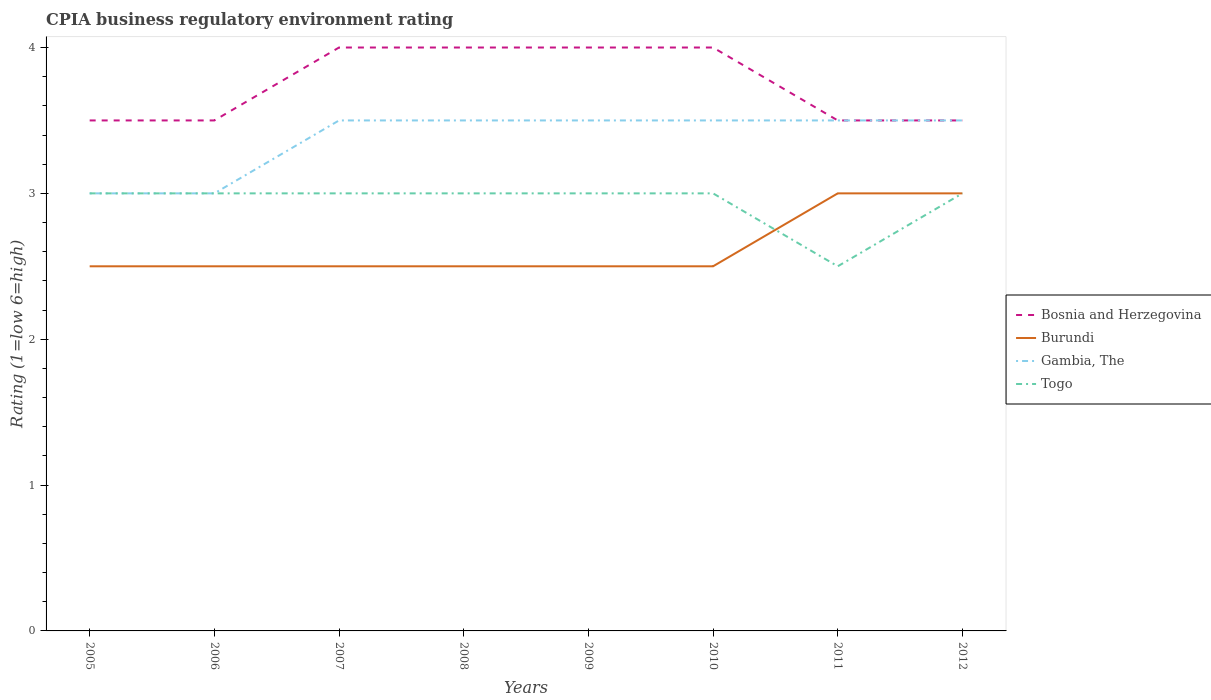Does the line corresponding to Bosnia and Herzegovina intersect with the line corresponding to Togo?
Provide a short and direct response. No. Across all years, what is the maximum CPIA rating in Gambia, The?
Provide a short and direct response. 3. In which year was the CPIA rating in Gambia, The maximum?
Keep it short and to the point. 2005. What is the total CPIA rating in Burundi in the graph?
Offer a terse response. -0.5. What is the difference between the highest and the second highest CPIA rating in Bosnia and Herzegovina?
Provide a short and direct response. 0.5. What is the difference between the highest and the lowest CPIA rating in Burundi?
Provide a short and direct response. 2. Is the CPIA rating in Gambia, The strictly greater than the CPIA rating in Togo over the years?
Give a very brief answer. No. How many lines are there?
Provide a succinct answer. 4. How many years are there in the graph?
Your answer should be compact. 8. Are the values on the major ticks of Y-axis written in scientific E-notation?
Offer a very short reply. No. Does the graph contain any zero values?
Give a very brief answer. No. How are the legend labels stacked?
Provide a short and direct response. Vertical. What is the title of the graph?
Keep it short and to the point. CPIA business regulatory environment rating. Does "Small states" appear as one of the legend labels in the graph?
Your answer should be very brief. No. What is the Rating (1=low 6=high) of Bosnia and Herzegovina in 2005?
Give a very brief answer. 3.5. What is the Rating (1=low 6=high) in Togo in 2006?
Provide a short and direct response. 3. What is the Rating (1=low 6=high) in Burundi in 2007?
Your answer should be very brief. 2.5. What is the Rating (1=low 6=high) in Togo in 2007?
Give a very brief answer. 3. What is the Rating (1=low 6=high) in Bosnia and Herzegovina in 2008?
Your answer should be compact. 4. What is the Rating (1=low 6=high) in Bosnia and Herzegovina in 2009?
Give a very brief answer. 4. What is the Rating (1=low 6=high) of Burundi in 2009?
Keep it short and to the point. 2.5. What is the Rating (1=low 6=high) of Gambia, The in 2009?
Provide a short and direct response. 3.5. What is the Rating (1=low 6=high) of Togo in 2010?
Keep it short and to the point. 3. What is the Rating (1=low 6=high) in Burundi in 2011?
Your response must be concise. 3. What is the Rating (1=low 6=high) in Bosnia and Herzegovina in 2012?
Ensure brevity in your answer.  3.5. What is the Rating (1=low 6=high) in Burundi in 2012?
Provide a short and direct response. 3. What is the Rating (1=low 6=high) in Gambia, The in 2012?
Provide a succinct answer. 3.5. What is the Rating (1=low 6=high) in Togo in 2012?
Give a very brief answer. 3. Across all years, what is the maximum Rating (1=low 6=high) in Bosnia and Herzegovina?
Offer a terse response. 4. Across all years, what is the minimum Rating (1=low 6=high) of Burundi?
Your response must be concise. 2.5. Across all years, what is the minimum Rating (1=low 6=high) in Gambia, The?
Provide a short and direct response. 3. Across all years, what is the minimum Rating (1=low 6=high) in Togo?
Your answer should be very brief. 2.5. What is the total Rating (1=low 6=high) in Burundi in the graph?
Offer a very short reply. 21. What is the total Rating (1=low 6=high) in Togo in the graph?
Make the answer very short. 23.5. What is the difference between the Rating (1=low 6=high) of Bosnia and Herzegovina in 2005 and that in 2006?
Make the answer very short. 0. What is the difference between the Rating (1=low 6=high) in Burundi in 2005 and that in 2006?
Make the answer very short. 0. What is the difference between the Rating (1=low 6=high) in Gambia, The in 2005 and that in 2006?
Provide a succinct answer. 0. What is the difference between the Rating (1=low 6=high) in Togo in 2005 and that in 2006?
Ensure brevity in your answer.  0. What is the difference between the Rating (1=low 6=high) in Togo in 2005 and that in 2007?
Your answer should be very brief. 0. What is the difference between the Rating (1=low 6=high) in Bosnia and Herzegovina in 2005 and that in 2008?
Provide a succinct answer. -0.5. What is the difference between the Rating (1=low 6=high) in Burundi in 2005 and that in 2008?
Provide a succinct answer. 0. What is the difference between the Rating (1=low 6=high) of Togo in 2005 and that in 2008?
Ensure brevity in your answer.  0. What is the difference between the Rating (1=low 6=high) of Bosnia and Herzegovina in 2005 and that in 2009?
Offer a terse response. -0.5. What is the difference between the Rating (1=low 6=high) in Gambia, The in 2005 and that in 2009?
Give a very brief answer. -0.5. What is the difference between the Rating (1=low 6=high) in Burundi in 2005 and that in 2010?
Provide a succinct answer. 0. What is the difference between the Rating (1=low 6=high) of Gambia, The in 2005 and that in 2010?
Ensure brevity in your answer.  -0.5. What is the difference between the Rating (1=low 6=high) of Togo in 2005 and that in 2010?
Keep it short and to the point. 0. What is the difference between the Rating (1=low 6=high) in Togo in 2005 and that in 2011?
Make the answer very short. 0.5. What is the difference between the Rating (1=low 6=high) in Bosnia and Herzegovina in 2005 and that in 2012?
Provide a succinct answer. 0. What is the difference between the Rating (1=low 6=high) in Gambia, The in 2005 and that in 2012?
Your answer should be compact. -0.5. What is the difference between the Rating (1=low 6=high) of Burundi in 2006 and that in 2007?
Offer a terse response. 0. What is the difference between the Rating (1=low 6=high) in Bosnia and Herzegovina in 2006 and that in 2008?
Keep it short and to the point. -0.5. What is the difference between the Rating (1=low 6=high) of Gambia, The in 2006 and that in 2008?
Provide a succinct answer. -0.5. What is the difference between the Rating (1=low 6=high) of Togo in 2006 and that in 2008?
Make the answer very short. 0. What is the difference between the Rating (1=low 6=high) in Bosnia and Herzegovina in 2006 and that in 2009?
Your answer should be compact. -0.5. What is the difference between the Rating (1=low 6=high) of Gambia, The in 2006 and that in 2009?
Provide a succinct answer. -0.5. What is the difference between the Rating (1=low 6=high) in Togo in 2006 and that in 2009?
Make the answer very short. 0. What is the difference between the Rating (1=low 6=high) in Bosnia and Herzegovina in 2006 and that in 2010?
Your answer should be very brief. -0.5. What is the difference between the Rating (1=low 6=high) in Burundi in 2006 and that in 2010?
Give a very brief answer. 0. What is the difference between the Rating (1=low 6=high) in Gambia, The in 2006 and that in 2010?
Your answer should be compact. -0.5. What is the difference between the Rating (1=low 6=high) in Togo in 2006 and that in 2010?
Give a very brief answer. 0. What is the difference between the Rating (1=low 6=high) of Burundi in 2006 and that in 2011?
Offer a very short reply. -0.5. What is the difference between the Rating (1=low 6=high) of Togo in 2006 and that in 2011?
Keep it short and to the point. 0.5. What is the difference between the Rating (1=low 6=high) in Burundi in 2006 and that in 2012?
Offer a terse response. -0.5. What is the difference between the Rating (1=low 6=high) in Gambia, The in 2006 and that in 2012?
Ensure brevity in your answer.  -0.5. What is the difference between the Rating (1=low 6=high) of Bosnia and Herzegovina in 2007 and that in 2008?
Ensure brevity in your answer.  0. What is the difference between the Rating (1=low 6=high) in Burundi in 2007 and that in 2008?
Make the answer very short. 0. What is the difference between the Rating (1=low 6=high) of Gambia, The in 2007 and that in 2008?
Offer a terse response. 0. What is the difference between the Rating (1=low 6=high) of Burundi in 2007 and that in 2009?
Offer a very short reply. 0. What is the difference between the Rating (1=low 6=high) of Togo in 2007 and that in 2009?
Your response must be concise. 0. What is the difference between the Rating (1=low 6=high) of Burundi in 2007 and that in 2010?
Your answer should be very brief. 0. What is the difference between the Rating (1=low 6=high) in Togo in 2007 and that in 2010?
Your answer should be compact. 0. What is the difference between the Rating (1=low 6=high) of Bosnia and Herzegovina in 2007 and that in 2011?
Your response must be concise. 0.5. What is the difference between the Rating (1=low 6=high) of Burundi in 2007 and that in 2011?
Ensure brevity in your answer.  -0.5. What is the difference between the Rating (1=low 6=high) in Bosnia and Herzegovina in 2008 and that in 2010?
Offer a very short reply. 0. What is the difference between the Rating (1=low 6=high) of Burundi in 2008 and that in 2010?
Offer a terse response. 0. What is the difference between the Rating (1=low 6=high) of Togo in 2008 and that in 2010?
Provide a succinct answer. 0. What is the difference between the Rating (1=low 6=high) of Bosnia and Herzegovina in 2008 and that in 2011?
Keep it short and to the point. 0.5. What is the difference between the Rating (1=low 6=high) in Burundi in 2008 and that in 2011?
Your answer should be very brief. -0.5. What is the difference between the Rating (1=low 6=high) of Burundi in 2008 and that in 2012?
Ensure brevity in your answer.  -0.5. What is the difference between the Rating (1=low 6=high) in Gambia, The in 2008 and that in 2012?
Provide a short and direct response. 0. What is the difference between the Rating (1=low 6=high) in Togo in 2008 and that in 2012?
Your answer should be compact. 0. What is the difference between the Rating (1=low 6=high) in Bosnia and Herzegovina in 2009 and that in 2010?
Your response must be concise. 0. What is the difference between the Rating (1=low 6=high) in Togo in 2009 and that in 2010?
Make the answer very short. 0. What is the difference between the Rating (1=low 6=high) in Burundi in 2009 and that in 2011?
Offer a terse response. -0.5. What is the difference between the Rating (1=low 6=high) in Togo in 2009 and that in 2011?
Make the answer very short. 0.5. What is the difference between the Rating (1=low 6=high) of Bosnia and Herzegovina in 2010 and that in 2011?
Offer a terse response. 0.5. What is the difference between the Rating (1=low 6=high) in Burundi in 2010 and that in 2011?
Offer a terse response. -0.5. What is the difference between the Rating (1=low 6=high) of Togo in 2010 and that in 2011?
Your answer should be compact. 0.5. What is the difference between the Rating (1=low 6=high) of Bosnia and Herzegovina in 2010 and that in 2012?
Your answer should be very brief. 0.5. What is the difference between the Rating (1=low 6=high) of Togo in 2010 and that in 2012?
Make the answer very short. 0. What is the difference between the Rating (1=low 6=high) of Burundi in 2011 and that in 2012?
Your response must be concise. 0. What is the difference between the Rating (1=low 6=high) of Togo in 2011 and that in 2012?
Make the answer very short. -0.5. What is the difference between the Rating (1=low 6=high) in Bosnia and Herzegovina in 2005 and the Rating (1=low 6=high) in Togo in 2006?
Your answer should be compact. 0.5. What is the difference between the Rating (1=low 6=high) in Burundi in 2005 and the Rating (1=low 6=high) in Togo in 2006?
Your response must be concise. -0.5. What is the difference between the Rating (1=low 6=high) in Gambia, The in 2005 and the Rating (1=low 6=high) in Togo in 2006?
Your answer should be very brief. 0. What is the difference between the Rating (1=low 6=high) of Bosnia and Herzegovina in 2005 and the Rating (1=low 6=high) of Burundi in 2007?
Provide a short and direct response. 1. What is the difference between the Rating (1=low 6=high) of Burundi in 2005 and the Rating (1=low 6=high) of Togo in 2007?
Provide a short and direct response. -0.5. What is the difference between the Rating (1=low 6=high) in Bosnia and Herzegovina in 2005 and the Rating (1=low 6=high) in Burundi in 2008?
Keep it short and to the point. 1. What is the difference between the Rating (1=low 6=high) of Bosnia and Herzegovina in 2005 and the Rating (1=low 6=high) of Gambia, The in 2008?
Offer a terse response. 0. What is the difference between the Rating (1=low 6=high) in Gambia, The in 2005 and the Rating (1=low 6=high) in Togo in 2008?
Ensure brevity in your answer.  0. What is the difference between the Rating (1=low 6=high) in Bosnia and Herzegovina in 2005 and the Rating (1=low 6=high) in Gambia, The in 2009?
Give a very brief answer. 0. What is the difference between the Rating (1=low 6=high) in Gambia, The in 2005 and the Rating (1=low 6=high) in Togo in 2009?
Provide a succinct answer. 0. What is the difference between the Rating (1=low 6=high) in Bosnia and Herzegovina in 2005 and the Rating (1=low 6=high) in Burundi in 2010?
Provide a short and direct response. 1. What is the difference between the Rating (1=low 6=high) in Bosnia and Herzegovina in 2005 and the Rating (1=low 6=high) in Gambia, The in 2010?
Provide a short and direct response. 0. What is the difference between the Rating (1=low 6=high) of Bosnia and Herzegovina in 2005 and the Rating (1=low 6=high) of Togo in 2010?
Offer a terse response. 0.5. What is the difference between the Rating (1=low 6=high) of Burundi in 2005 and the Rating (1=low 6=high) of Gambia, The in 2010?
Your answer should be compact. -1. What is the difference between the Rating (1=low 6=high) of Burundi in 2005 and the Rating (1=low 6=high) of Togo in 2010?
Offer a terse response. -0.5. What is the difference between the Rating (1=low 6=high) in Gambia, The in 2005 and the Rating (1=low 6=high) in Togo in 2010?
Give a very brief answer. 0. What is the difference between the Rating (1=low 6=high) in Bosnia and Herzegovina in 2005 and the Rating (1=low 6=high) in Burundi in 2011?
Provide a short and direct response. 0.5. What is the difference between the Rating (1=low 6=high) of Bosnia and Herzegovina in 2005 and the Rating (1=low 6=high) of Togo in 2011?
Keep it short and to the point. 1. What is the difference between the Rating (1=low 6=high) of Burundi in 2005 and the Rating (1=low 6=high) of Gambia, The in 2011?
Provide a succinct answer. -1. What is the difference between the Rating (1=low 6=high) in Bosnia and Herzegovina in 2005 and the Rating (1=low 6=high) in Burundi in 2012?
Ensure brevity in your answer.  0.5. What is the difference between the Rating (1=low 6=high) of Burundi in 2005 and the Rating (1=low 6=high) of Togo in 2012?
Your answer should be compact. -0.5. What is the difference between the Rating (1=low 6=high) of Gambia, The in 2005 and the Rating (1=low 6=high) of Togo in 2012?
Provide a succinct answer. 0. What is the difference between the Rating (1=low 6=high) in Bosnia and Herzegovina in 2006 and the Rating (1=low 6=high) in Gambia, The in 2007?
Provide a short and direct response. 0. What is the difference between the Rating (1=low 6=high) in Burundi in 2006 and the Rating (1=low 6=high) in Togo in 2008?
Ensure brevity in your answer.  -0.5. What is the difference between the Rating (1=low 6=high) of Gambia, The in 2006 and the Rating (1=low 6=high) of Togo in 2008?
Provide a succinct answer. 0. What is the difference between the Rating (1=low 6=high) in Burundi in 2006 and the Rating (1=low 6=high) in Gambia, The in 2009?
Ensure brevity in your answer.  -1. What is the difference between the Rating (1=low 6=high) of Gambia, The in 2006 and the Rating (1=low 6=high) of Togo in 2009?
Make the answer very short. 0. What is the difference between the Rating (1=low 6=high) of Bosnia and Herzegovina in 2006 and the Rating (1=low 6=high) of Togo in 2010?
Your answer should be compact. 0.5. What is the difference between the Rating (1=low 6=high) of Burundi in 2006 and the Rating (1=low 6=high) of Togo in 2010?
Offer a very short reply. -0.5. What is the difference between the Rating (1=low 6=high) in Gambia, The in 2006 and the Rating (1=low 6=high) in Togo in 2010?
Provide a succinct answer. 0. What is the difference between the Rating (1=low 6=high) in Bosnia and Herzegovina in 2006 and the Rating (1=low 6=high) in Gambia, The in 2011?
Provide a succinct answer. 0. What is the difference between the Rating (1=low 6=high) of Bosnia and Herzegovina in 2006 and the Rating (1=low 6=high) of Togo in 2011?
Provide a short and direct response. 1. What is the difference between the Rating (1=low 6=high) in Gambia, The in 2006 and the Rating (1=low 6=high) in Togo in 2011?
Provide a succinct answer. 0.5. What is the difference between the Rating (1=low 6=high) of Bosnia and Herzegovina in 2006 and the Rating (1=low 6=high) of Togo in 2012?
Ensure brevity in your answer.  0.5. What is the difference between the Rating (1=low 6=high) of Burundi in 2006 and the Rating (1=low 6=high) of Gambia, The in 2012?
Offer a terse response. -1. What is the difference between the Rating (1=low 6=high) of Burundi in 2006 and the Rating (1=low 6=high) of Togo in 2012?
Ensure brevity in your answer.  -0.5. What is the difference between the Rating (1=low 6=high) of Gambia, The in 2006 and the Rating (1=low 6=high) of Togo in 2012?
Give a very brief answer. 0. What is the difference between the Rating (1=low 6=high) in Bosnia and Herzegovina in 2007 and the Rating (1=low 6=high) in Burundi in 2008?
Your answer should be compact. 1.5. What is the difference between the Rating (1=low 6=high) of Bosnia and Herzegovina in 2007 and the Rating (1=low 6=high) of Gambia, The in 2008?
Your answer should be very brief. 0.5. What is the difference between the Rating (1=low 6=high) in Burundi in 2007 and the Rating (1=low 6=high) in Gambia, The in 2008?
Your answer should be compact. -1. What is the difference between the Rating (1=low 6=high) of Burundi in 2007 and the Rating (1=low 6=high) of Togo in 2008?
Your response must be concise. -0.5. What is the difference between the Rating (1=low 6=high) in Gambia, The in 2007 and the Rating (1=low 6=high) in Togo in 2008?
Give a very brief answer. 0.5. What is the difference between the Rating (1=low 6=high) in Bosnia and Herzegovina in 2007 and the Rating (1=low 6=high) in Burundi in 2009?
Your answer should be compact. 1.5. What is the difference between the Rating (1=low 6=high) of Bosnia and Herzegovina in 2007 and the Rating (1=low 6=high) of Gambia, The in 2009?
Offer a terse response. 0.5. What is the difference between the Rating (1=low 6=high) in Bosnia and Herzegovina in 2007 and the Rating (1=low 6=high) in Togo in 2009?
Provide a succinct answer. 1. What is the difference between the Rating (1=low 6=high) in Burundi in 2007 and the Rating (1=low 6=high) in Gambia, The in 2009?
Offer a terse response. -1. What is the difference between the Rating (1=low 6=high) of Burundi in 2007 and the Rating (1=low 6=high) of Togo in 2009?
Your answer should be very brief. -0.5. What is the difference between the Rating (1=low 6=high) of Bosnia and Herzegovina in 2007 and the Rating (1=low 6=high) of Togo in 2010?
Keep it short and to the point. 1. What is the difference between the Rating (1=low 6=high) of Burundi in 2007 and the Rating (1=low 6=high) of Gambia, The in 2010?
Keep it short and to the point. -1. What is the difference between the Rating (1=low 6=high) in Burundi in 2007 and the Rating (1=low 6=high) in Togo in 2010?
Provide a succinct answer. -0.5. What is the difference between the Rating (1=low 6=high) of Gambia, The in 2007 and the Rating (1=low 6=high) of Togo in 2010?
Provide a succinct answer. 0.5. What is the difference between the Rating (1=low 6=high) of Bosnia and Herzegovina in 2007 and the Rating (1=low 6=high) of Burundi in 2011?
Make the answer very short. 1. What is the difference between the Rating (1=low 6=high) of Bosnia and Herzegovina in 2007 and the Rating (1=low 6=high) of Togo in 2011?
Your response must be concise. 1.5. What is the difference between the Rating (1=low 6=high) of Burundi in 2007 and the Rating (1=low 6=high) of Gambia, The in 2011?
Give a very brief answer. -1. What is the difference between the Rating (1=low 6=high) in Bosnia and Herzegovina in 2007 and the Rating (1=low 6=high) in Togo in 2012?
Ensure brevity in your answer.  1. What is the difference between the Rating (1=low 6=high) of Burundi in 2007 and the Rating (1=low 6=high) of Togo in 2012?
Keep it short and to the point. -0.5. What is the difference between the Rating (1=low 6=high) of Gambia, The in 2007 and the Rating (1=low 6=high) of Togo in 2012?
Provide a succinct answer. 0.5. What is the difference between the Rating (1=low 6=high) of Bosnia and Herzegovina in 2008 and the Rating (1=low 6=high) of Gambia, The in 2009?
Give a very brief answer. 0.5. What is the difference between the Rating (1=low 6=high) in Bosnia and Herzegovina in 2008 and the Rating (1=low 6=high) in Togo in 2009?
Ensure brevity in your answer.  1. What is the difference between the Rating (1=low 6=high) of Burundi in 2008 and the Rating (1=low 6=high) of Gambia, The in 2009?
Your response must be concise. -1. What is the difference between the Rating (1=low 6=high) in Gambia, The in 2008 and the Rating (1=low 6=high) in Togo in 2009?
Give a very brief answer. 0.5. What is the difference between the Rating (1=low 6=high) in Bosnia and Herzegovina in 2008 and the Rating (1=low 6=high) in Gambia, The in 2010?
Offer a terse response. 0.5. What is the difference between the Rating (1=low 6=high) of Bosnia and Herzegovina in 2008 and the Rating (1=low 6=high) of Togo in 2010?
Provide a succinct answer. 1. What is the difference between the Rating (1=low 6=high) of Burundi in 2008 and the Rating (1=low 6=high) of Gambia, The in 2010?
Offer a terse response. -1. What is the difference between the Rating (1=low 6=high) of Gambia, The in 2008 and the Rating (1=low 6=high) of Togo in 2010?
Keep it short and to the point. 0.5. What is the difference between the Rating (1=low 6=high) of Bosnia and Herzegovina in 2008 and the Rating (1=low 6=high) of Burundi in 2011?
Give a very brief answer. 1. What is the difference between the Rating (1=low 6=high) in Bosnia and Herzegovina in 2008 and the Rating (1=low 6=high) in Togo in 2011?
Offer a terse response. 1.5. What is the difference between the Rating (1=low 6=high) of Burundi in 2008 and the Rating (1=low 6=high) of Togo in 2011?
Your response must be concise. 0. What is the difference between the Rating (1=low 6=high) in Bosnia and Herzegovina in 2008 and the Rating (1=low 6=high) in Gambia, The in 2012?
Your answer should be very brief. 0.5. What is the difference between the Rating (1=low 6=high) in Bosnia and Herzegovina in 2008 and the Rating (1=low 6=high) in Togo in 2012?
Make the answer very short. 1. What is the difference between the Rating (1=low 6=high) of Burundi in 2008 and the Rating (1=low 6=high) of Togo in 2012?
Give a very brief answer. -0.5. What is the difference between the Rating (1=low 6=high) in Bosnia and Herzegovina in 2009 and the Rating (1=low 6=high) in Burundi in 2010?
Your answer should be very brief. 1.5. What is the difference between the Rating (1=low 6=high) in Bosnia and Herzegovina in 2009 and the Rating (1=low 6=high) in Togo in 2010?
Your response must be concise. 1. What is the difference between the Rating (1=low 6=high) of Burundi in 2009 and the Rating (1=low 6=high) of Gambia, The in 2010?
Your answer should be very brief. -1. What is the difference between the Rating (1=low 6=high) of Gambia, The in 2009 and the Rating (1=low 6=high) of Togo in 2010?
Ensure brevity in your answer.  0.5. What is the difference between the Rating (1=low 6=high) in Bosnia and Herzegovina in 2009 and the Rating (1=low 6=high) in Togo in 2011?
Provide a short and direct response. 1.5. What is the difference between the Rating (1=low 6=high) in Burundi in 2009 and the Rating (1=low 6=high) in Gambia, The in 2011?
Give a very brief answer. -1. What is the difference between the Rating (1=low 6=high) of Gambia, The in 2009 and the Rating (1=low 6=high) of Togo in 2011?
Make the answer very short. 1. What is the difference between the Rating (1=low 6=high) in Bosnia and Herzegovina in 2009 and the Rating (1=low 6=high) in Togo in 2012?
Provide a succinct answer. 1. What is the difference between the Rating (1=low 6=high) in Burundi in 2009 and the Rating (1=low 6=high) in Gambia, The in 2012?
Your answer should be compact. -1. What is the difference between the Rating (1=low 6=high) of Bosnia and Herzegovina in 2010 and the Rating (1=low 6=high) of Burundi in 2011?
Make the answer very short. 1. What is the difference between the Rating (1=low 6=high) of Burundi in 2010 and the Rating (1=low 6=high) of Togo in 2011?
Your answer should be compact. 0. What is the difference between the Rating (1=low 6=high) of Gambia, The in 2010 and the Rating (1=low 6=high) of Togo in 2011?
Your answer should be very brief. 1. What is the difference between the Rating (1=low 6=high) in Bosnia and Herzegovina in 2010 and the Rating (1=low 6=high) in Togo in 2012?
Offer a terse response. 1. What is the difference between the Rating (1=low 6=high) of Burundi in 2010 and the Rating (1=low 6=high) of Gambia, The in 2012?
Provide a short and direct response. -1. What is the difference between the Rating (1=low 6=high) in Gambia, The in 2010 and the Rating (1=low 6=high) in Togo in 2012?
Offer a terse response. 0.5. What is the difference between the Rating (1=low 6=high) in Bosnia and Herzegovina in 2011 and the Rating (1=low 6=high) in Gambia, The in 2012?
Your answer should be very brief. 0. What is the difference between the Rating (1=low 6=high) of Bosnia and Herzegovina in 2011 and the Rating (1=low 6=high) of Togo in 2012?
Offer a very short reply. 0.5. What is the difference between the Rating (1=low 6=high) in Gambia, The in 2011 and the Rating (1=low 6=high) in Togo in 2012?
Ensure brevity in your answer.  0.5. What is the average Rating (1=low 6=high) of Bosnia and Herzegovina per year?
Your answer should be compact. 3.75. What is the average Rating (1=low 6=high) in Burundi per year?
Your response must be concise. 2.62. What is the average Rating (1=low 6=high) of Gambia, The per year?
Ensure brevity in your answer.  3.38. What is the average Rating (1=low 6=high) in Togo per year?
Provide a succinct answer. 2.94. In the year 2005, what is the difference between the Rating (1=low 6=high) in Bosnia and Herzegovina and Rating (1=low 6=high) in Gambia, The?
Ensure brevity in your answer.  0.5. In the year 2005, what is the difference between the Rating (1=low 6=high) in Bosnia and Herzegovina and Rating (1=low 6=high) in Togo?
Make the answer very short. 0.5. In the year 2005, what is the difference between the Rating (1=low 6=high) of Burundi and Rating (1=low 6=high) of Gambia, The?
Offer a terse response. -0.5. In the year 2005, what is the difference between the Rating (1=low 6=high) of Burundi and Rating (1=low 6=high) of Togo?
Your answer should be very brief. -0.5. In the year 2006, what is the difference between the Rating (1=low 6=high) of Bosnia and Herzegovina and Rating (1=low 6=high) of Burundi?
Keep it short and to the point. 1. In the year 2006, what is the difference between the Rating (1=low 6=high) in Bosnia and Herzegovina and Rating (1=low 6=high) in Gambia, The?
Offer a very short reply. 0.5. In the year 2006, what is the difference between the Rating (1=low 6=high) of Bosnia and Herzegovina and Rating (1=low 6=high) of Togo?
Your answer should be very brief. 0.5. In the year 2006, what is the difference between the Rating (1=low 6=high) in Gambia, The and Rating (1=low 6=high) in Togo?
Offer a very short reply. 0. In the year 2007, what is the difference between the Rating (1=low 6=high) of Bosnia and Herzegovina and Rating (1=low 6=high) of Burundi?
Your answer should be very brief. 1.5. In the year 2007, what is the difference between the Rating (1=low 6=high) in Bosnia and Herzegovina and Rating (1=low 6=high) in Gambia, The?
Offer a terse response. 0.5. In the year 2007, what is the difference between the Rating (1=low 6=high) in Gambia, The and Rating (1=low 6=high) in Togo?
Your answer should be compact. 0.5. In the year 2008, what is the difference between the Rating (1=low 6=high) of Bosnia and Herzegovina and Rating (1=low 6=high) of Burundi?
Provide a short and direct response. 1.5. In the year 2008, what is the difference between the Rating (1=low 6=high) of Bosnia and Herzegovina and Rating (1=low 6=high) of Gambia, The?
Your answer should be very brief. 0.5. In the year 2008, what is the difference between the Rating (1=low 6=high) of Burundi and Rating (1=low 6=high) of Gambia, The?
Give a very brief answer. -1. In the year 2009, what is the difference between the Rating (1=low 6=high) in Bosnia and Herzegovina and Rating (1=low 6=high) in Gambia, The?
Provide a short and direct response. 0.5. In the year 2009, what is the difference between the Rating (1=low 6=high) of Bosnia and Herzegovina and Rating (1=low 6=high) of Togo?
Provide a short and direct response. 1. In the year 2009, what is the difference between the Rating (1=low 6=high) of Burundi and Rating (1=low 6=high) of Gambia, The?
Your response must be concise. -1. In the year 2009, what is the difference between the Rating (1=low 6=high) of Burundi and Rating (1=low 6=high) of Togo?
Provide a short and direct response. -0.5. In the year 2010, what is the difference between the Rating (1=low 6=high) of Bosnia and Herzegovina and Rating (1=low 6=high) of Togo?
Keep it short and to the point. 1. In the year 2010, what is the difference between the Rating (1=low 6=high) of Burundi and Rating (1=low 6=high) of Togo?
Ensure brevity in your answer.  -0.5. In the year 2011, what is the difference between the Rating (1=low 6=high) of Bosnia and Herzegovina and Rating (1=low 6=high) of Burundi?
Your response must be concise. 0.5. In the year 2011, what is the difference between the Rating (1=low 6=high) of Bosnia and Herzegovina and Rating (1=low 6=high) of Togo?
Make the answer very short. 1. In the year 2011, what is the difference between the Rating (1=low 6=high) of Burundi and Rating (1=low 6=high) of Gambia, The?
Provide a succinct answer. -0.5. In the year 2011, what is the difference between the Rating (1=low 6=high) of Burundi and Rating (1=low 6=high) of Togo?
Provide a short and direct response. 0.5. In the year 2012, what is the difference between the Rating (1=low 6=high) of Bosnia and Herzegovina and Rating (1=low 6=high) of Gambia, The?
Your response must be concise. 0. In the year 2012, what is the difference between the Rating (1=low 6=high) in Bosnia and Herzegovina and Rating (1=low 6=high) in Togo?
Keep it short and to the point. 0.5. In the year 2012, what is the difference between the Rating (1=low 6=high) in Burundi and Rating (1=low 6=high) in Gambia, The?
Your answer should be very brief. -0.5. In the year 2012, what is the difference between the Rating (1=low 6=high) in Gambia, The and Rating (1=low 6=high) in Togo?
Ensure brevity in your answer.  0.5. What is the ratio of the Rating (1=low 6=high) of Burundi in 2005 to that in 2006?
Give a very brief answer. 1. What is the ratio of the Rating (1=low 6=high) of Gambia, The in 2005 to that in 2006?
Your answer should be compact. 1. What is the ratio of the Rating (1=low 6=high) in Togo in 2005 to that in 2006?
Offer a terse response. 1. What is the ratio of the Rating (1=low 6=high) in Gambia, The in 2005 to that in 2007?
Your answer should be very brief. 0.86. What is the ratio of the Rating (1=low 6=high) of Bosnia and Herzegovina in 2005 to that in 2008?
Your response must be concise. 0.88. What is the ratio of the Rating (1=low 6=high) of Burundi in 2005 to that in 2008?
Give a very brief answer. 1. What is the ratio of the Rating (1=low 6=high) in Gambia, The in 2005 to that in 2008?
Give a very brief answer. 0.86. What is the ratio of the Rating (1=low 6=high) of Gambia, The in 2005 to that in 2009?
Offer a very short reply. 0.86. What is the ratio of the Rating (1=low 6=high) of Burundi in 2005 to that in 2010?
Keep it short and to the point. 1. What is the ratio of the Rating (1=low 6=high) in Togo in 2005 to that in 2010?
Offer a terse response. 1. What is the ratio of the Rating (1=low 6=high) of Bosnia and Herzegovina in 2005 to that in 2011?
Keep it short and to the point. 1. What is the ratio of the Rating (1=low 6=high) of Burundi in 2005 to that in 2011?
Offer a terse response. 0.83. What is the ratio of the Rating (1=low 6=high) of Gambia, The in 2005 to that in 2011?
Your response must be concise. 0.86. What is the ratio of the Rating (1=low 6=high) of Bosnia and Herzegovina in 2005 to that in 2012?
Make the answer very short. 1. What is the ratio of the Rating (1=low 6=high) in Gambia, The in 2005 to that in 2012?
Your answer should be very brief. 0.86. What is the ratio of the Rating (1=low 6=high) of Burundi in 2006 to that in 2007?
Make the answer very short. 1. What is the ratio of the Rating (1=low 6=high) of Gambia, The in 2006 to that in 2007?
Ensure brevity in your answer.  0.86. What is the ratio of the Rating (1=low 6=high) of Bosnia and Herzegovina in 2006 to that in 2008?
Make the answer very short. 0.88. What is the ratio of the Rating (1=low 6=high) of Gambia, The in 2006 to that in 2008?
Make the answer very short. 0.86. What is the ratio of the Rating (1=low 6=high) of Bosnia and Herzegovina in 2006 to that in 2009?
Make the answer very short. 0.88. What is the ratio of the Rating (1=low 6=high) of Burundi in 2006 to that in 2009?
Provide a succinct answer. 1. What is the ratio of the Rating (1=low 6=high) of Togo in 2006 to that in 2009?
Offer a very short reply. 1. What is the ratio of the Rating (1=low 6=high) in Bosnia and Herzegovina in 2006 to that in 2010?
Provide a succinct answer. 0.88. What is the ratio of the Rating (1=low 6=high) in Bosnia and Herzegovina in 2006 to that in 2011?
Your answer should be compact. 1. What is the ratio of the Rating (1=low 6=high) in Gambia, The in 2006 to that in 2011?
Keep it short and to the point. 0.86. What is the ratio of the Rating (1=low 6=high) in Togo in 2006 to that in 2012?
Keep it short and to the point. 1. What is the ratio of the Rating (1=low 6=high) in Burundi in 2007 to that in 2008?
Give a very brief answer. 1. What is the ratio of the Rating (1=low 6=high) in Togo in 2007 to that in 2008?
Provide a succinct answer. 1. What is the ratio of the Rating (1=low 6=high) of Burundi in 2007 to that in 2009?
Provide a short and direct response. 1. What is the ratio of the Rating (1=low 6=high) of Gambia, The in 2007 to that in 2009?
Provide a short and direct response. 1. What is the ratio of the Rating (1=low 6=high) of Gambia, The in 2007 to that in 2010?
Your answer should be compact. 1. What is the ratio of the Rating (1=low 6=high) of Togo in 2007 to that in 2010?
Make the answer very short. 1. What is the ratio of the Rating (1=low 6=high) of Bosnia and Herzegovina in 2007 to that in 2011?
Provide a short and direct response. 1.14. What is the ratio of the Rating (1=low 6=high) in Burundi in 2007 to that in 2011?
Make the answer very short. 0.83. What is the ratio of the Rating (1=low 6=high) in Gambia, The in 2007 to that in 2011?
Offer a very short reply. 1. What is the ratio of the Rating (1=low 6=high) of Burundi in 2007 to that in 2012?
Provide a short and direct response. 0.83. What is the ratio of the Rating (1=low 6=high) in Togo in 2007 to that in 2012?
Your response must be concise. 1. What is the ratio of the Rating (1=low 6=high) in Burundi in 2008 to that in 2009?
Give a very brief answer. 1. What is the ratio of the Rating (1=low 6=high) in Gambia, The in 2008 to that in 2010?
Your answer should be very brief. 1. What is the ratio of the Rating (1=low 6=high) of Burundi in 2008 to that in 2011?
Make the answer very short. 0.83. What is the ratio of the Rating (1=low 6=high) of Gambia, The in 2008 to that in 2011?
Make the answer very short. 1. What is the ratio of the Rating (1=low 6=high) in Togo in 2008 to that in 2011?
Provide a succinct answer. 1.2. What is the ratio of the Rating (1=low 6=high) in Bosnia and Herzegovina in 2009 to that in 2010?
Give a very brief answer. 1. What is the ratio of the Rating (1=low 6=high) in Burundi in 2009 to that in 2010?
Provide a succinct answer. 1. What is the ratio of the Rating (1=low 6=high) in Gambia, The in 2009 to that in 2010?
Provide a short and direct response. 1. What is the ratio of the Rating (1=low 6=high) in Bosnia and Herzegovina in 2009 to that in 2011?
Ensure brevity in your answer.  1.14. What is the ratio of the Rating (1=low 6=high) in Burundi in 2009 to that in 2011?
Ensure brevity in your answer.  0.83. What is the ratio of the Rating (1=low 6=high) in Togo in 2009 to that in 2011?
Your answer should be very brief. 1.2. What is the ratio of the Rating (1=low 6=high) of Burundi in 2009 to that in 2012?
Provide a succinct answer. 0.83. What is the ratio of the Rating (1=low 6=high) of Gambia, The in 2009 to that in 2012?
Provide a short and direct response. 1. What is the ratio of the Rating (1=low 6=high) in Gambia, The in 2010 to that in 2011?
Your response must be concise. 1. What is the ratio of the Rating (1=low 6=high) in Togo in 2010 to that in 2011?
Keep it short and to the point. 1.2. What is the ratio of the Rating (1=low 6=high) in Bosnia and Herzegovina in 2010 to that in 2012?
Provide a short and direct response. 1.14. What is the ratio of the Rating (1=low 6=high) of Gambia, The in 2010 to that in 2012?
Give a very brief answer. 1. What is the ratio of the Rating (1=low 6=high) of Bosnia and Herzegovina in 2011 to that in 2012?
Offer a terse response. 1. What is the difference between the highest and the second highest Rating (1=low 6=high) in Burundi?
Your answer should be compact. 0. What is the difference between the highest and the second highest Rating (1=low 6=high) of Gambia, The?
Offer a very short reply. 0. What is the difference between the highest and the second highest Rating (1=low 6=high) of Togo?
Keep it short and to the point. 0. What is the difference between the highest and the lowest Rating (1=low 6=high) of Bosnia and Herzegovina?
Your response must be concise. 0.5. What is the difference between the highest and the lowest Rating (1=low 6=high) in Gambia, The?
Your answer should be compact. 0.5. 